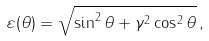<formula> <loc_0><loc_0><loc_500><loc_500>\varepsilon ( \theta ) = \sqrt { \sin ^ { 2 } \theta + \gamma ^ { 2 } \cos ^ { 2 } \theta } \, ,</formula> 